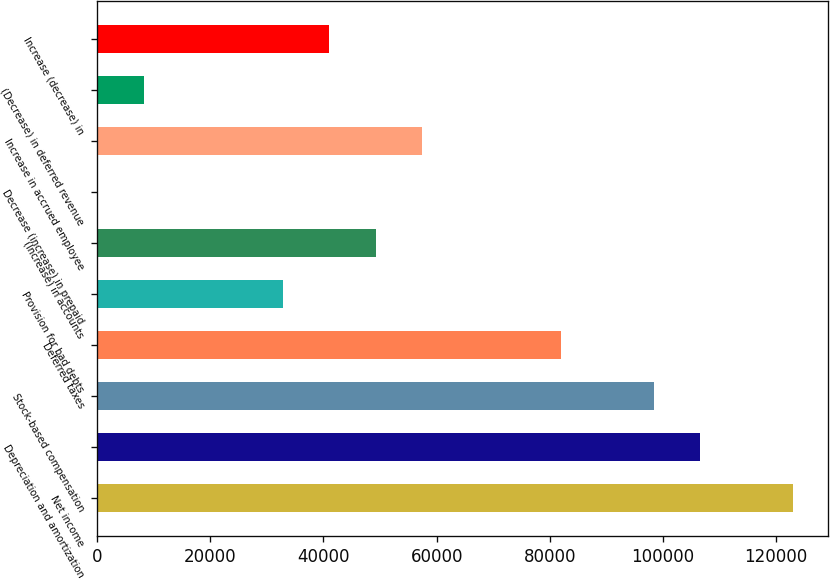Convert chart to OTSL. <chart><loc_0><loc_0><loc_500><loc_500><bar_chart><fcel>Net income<fcel>Depreciation and amortization<fcel>Stock-based compensation<fcel>Deferred taxes<fcel>Provision for bad debts<fcel>(Increase) in accounts<fcel>Decrease (increase) in prepaid<fcel>Increase in accrued employee<fcel>(Decrease) in deferred revenue<fcel>Increase (decrease) in<nl><fcel>122960<fcel>106576<fcel>98383.8<fcel>82000<fcel>32848.6<fcel>49232.4<fcel>81<fcel>57424.3<fcel>8272.9<fcel>41040.5<nl></chart> 